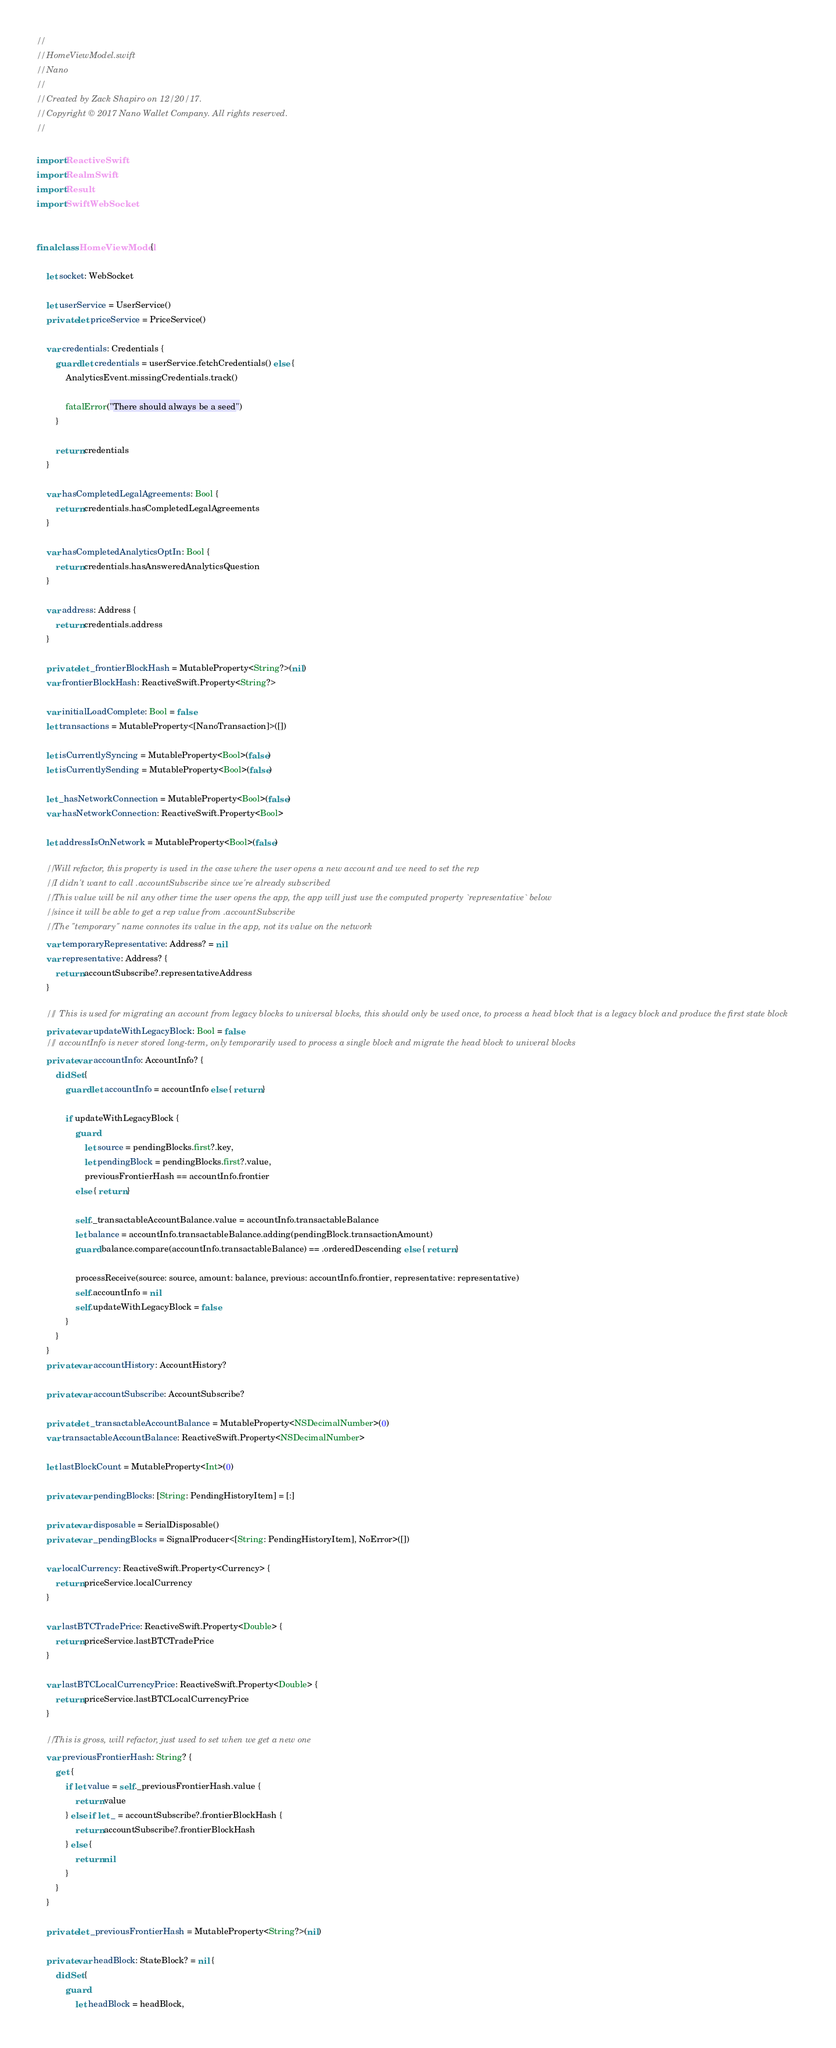<code> <loc_0><loc_0><loc_500><loc_500><_Swift_>//
//  HomeViewModel.swift
//  Nano
//
//  Created by Zack Shapiro on 12/20/17.
//  Copyright © 2017 Nano Wallet Company. All rights reserved.
//

import ReactiveSwift
import RealmSwift
import Result
import SwiftWebSocket


final class HomeViewModel {

    let socket: WebSocket

    let userService = UserService()
    private let priceService = PriceService()

    var credentials: Credentials {
        guard let credentials = userService.fetchCredentials() else {
            AnalyticsEvent.missingCredentials.track()

            fatalError("There should always be a seed")
        }

        return credentials
    }

    var hasCompletedLegalAgreements: Bool {
        return credentials.hasCompletedLegalAgreements
    }

    var hasCompletedAnalyticsOptIn: Bool {
        return credentials.hasAnsweredAnalyticsQuestion
    }

    var address: Address {
        return credentials.address
    }

    private let _frontierBlockHash = MutableProperty<String?>(nil)
    var frontierBlockHash: ReactiveSwift.Property<String?>

    var initialLoadComplete: Bool = false
    let transactions = MutableProperty<[NanoTransaction]>([])

    let isCurrentlySyncing = MutableProperty<Bool>(false)
    let isCurrentlySending = MutableProperty<Bool>(false)

    let _hasNetworkConnection = MutableProperty<Bool>(false)
    var hasNetworkConnection: ReactiveSwift.Property<Bool>

    let addressIsOnNetwork = MutableProperty<Bool>(false)

    // Will refactor, this property is used in the case where the user opens a new account and we need to set the rep
    // I didn't want to call .accountSubscribe since we're already subscribed
    // This value will be nil any other time the user opens the app, the app will just use the computed property `representative` below
    // since it will be able to get a rep value from .accountSubscribe
    // The "temporary" name connotes its value in the app, not its value on the network
    var temporaryRepresentative: Address? = nil
    var representative: Address? {
        return accountSubscribe?.representativeAddress
    }

    /// This is used for migrating an account from legacy blocks to universal blocks, this should only be used once, to process a head block that is a legacy block and produce the first state block
    private var updateWithLegacyBlock: Bool = false
    /// accountInfo is never stored long-term, only temporarily used to process a single block and migrate the head block to univeral blocks
    private var accountInfo: AccountInfo? {
        didSet {
            guard let accountInfo = accountInfo else { return }

            if updateWithLegacyBlock {
                guard
                    let source = pendingBlocks.first?.key,
                    let pendingBlock = pendingBlocks.first?.value,
                    previousFrontierHash == accountInfo.frontier
                else { return }

                self._transactableAccountBalance.value = accountInfo.transactableBalance
                let balance = accountInfo.transactableBalance.adding(pendingBlock.transactionAmount)
                guard balance.compare(accountInfo.transactableBalance) == .orderedDescending else { return }

                processReceive(source: source, amount: balance, previous: accountInfo.frontier, representative: representative)
                self.accountInfo = nil
                self.updateWithLegacyBlock = false
            }
        }
    }
    private var accountHistory: AccountHistory?

    private var accountSubscribe: AccountSubscribe?

    private let _transactableAccountBalance = MutableProperty<NSDecimalNumber>(0)
    var transactableAccountBalance: ReactiveSwift.Property<NSDecimalNumber>

    let lastBlockCount = MutableProperty<Int>(0)

    private var pendingBlocks: [String: PendingHistoryItem] = [:]

    private var disposable = SerialDisposable()
    private var _pendingBlocks = SignalProducer<[String: PendingHistoryItem], NoError>([])

    var localCurrency: ReactiveSwift.Property<Currency> {
        return priceService.localCurrency
    }

    var lastBTCTradePrice: ReactiveSwift.Property<Double> {
        return priceService.lastBTCTradePrice
    }

    var lastBTCLocalCurrencyPrice: ReactiveSwift.Property<Double> {
        return priceService.lastBTCLocalCurrencyPrice
    }

    // This is gross, will refactor, just used to set when we get a new one
    var previousFrontierHash: String? {
        get {
            if let value = self._previousFrontierHash.value {
                return value
            } else if let _ = accountSubscribe?.frontierBlockHash {
                return accountSubscribe?.frontierBlockHash
            } else {
                return nil
            }
        }
    }

    private let _previousFrontierHash = MutableProperty<String?>(nil)

    private var headBlock: StateBlock? = nil {
        didSet {
            guard
                let headBlock = headBlock,</code> 